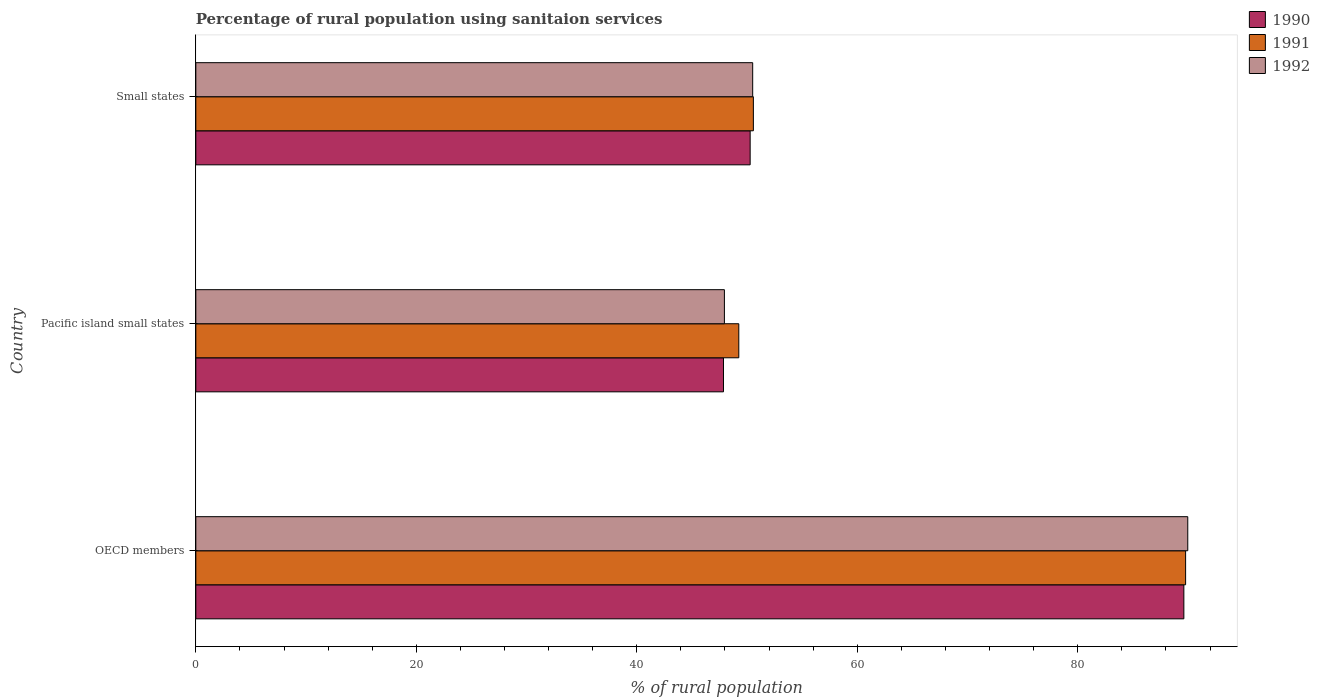Are the number of bars on each tick of the Y-axis equal?
Offer a terse response. Yes. What is the label of the 2nd group of bars from the top?
Offer a terse response. Pacific island small states. In how many cases, is the number of bars for a given country not equal to the number of legend labels?
Provide a succinct answer. 0. What is the percentage of rural population using sanitaion services in 1992 in Small states?
Your answer should be compact. 50.51. Across all countries, what is the maximum percentage of rural population using sanitaion services in 1992?
Offer a terse response. 89.98. Across all countries, what is the minimum percentage of rural population using sanitaion services in 1992?
Ensure brevity in your answer.  47.95. In which country was the percentage of rural population using sanitaion services in 1990 minimum?
Provide a short and direct response. Pacific island small states. What is the total percentage of rural population using sanitaion services in 1990 in the graph?
Provide a succinct answer. 187.77. What is the difference between the percentage of rural population using sanitaion services in 1990 in OECD members and that in Pacific island small states?
Ensure brevity in your answer.  41.76. What is the difference between the percentage of rural population using sanitaion services in 1992 in Pacific island small states and the percentage of rural population using sanitaion services in 1990 in OECD members?
Your response must be concise. -41.68. What is the average percentage of rural population using sanitaion services in 1992 per country?
Your response must be concise. 62.81. What is the difference between the percentage of rural population using sanitaion services in 1992 and percentage of rural population using sanitaion services in 1990 in Pacific island small states?
Give a very brief answer. 0.08. What is the ratio of the percentage of rural population using sanitaion services in 1992 in OECD members to that in Small states?
Your answer should be compact. 1.78. What is the difference between the highest and the second highest percentage of rural population using sanitaion services in 1991?
Your answer should be compact. 39.21. What is the difference between the highest and the lowest percentage of rural population using sanitaion services in 1991?
Offer a very short reply. 40.53. Is the sum of the percentage of rural population using sanitaion services in 1990 in OECD members and Pacific island small states greater than the maximum percentage of rural population using sanitaion services in 1992 across all countries?
Your response must be concise. Yes. What does the 3rd bar from the bottom in OECD members represents?
Offer a very short reply. 1992. How many bars are there?
Offer a terse response. 9. Are all the bars in the graph horizontal?
Offer a terse response. Yes. How many countries are there in the graph?
Offer a terse response. 3. What is the difference between two consecutive major ticks on the X-axis?
Your answer should be very brief. 20. Are the values on the major ticks of X-axis written in scientific E-notation?
Ensure brevity in your answer.  No. Does the graph contain any zero values?
Your response must be concise. No. What is the title of the graph?
Your answer should be compact. Percentage of rural population using sanitaion services. Does "1961" appear as one of the legend labels in the graph?
Give a very brief answer. No. What is the label or title of the X-axis?
Make the answer very short. % of rural population. What is the % of rural population in 1990 in OECD members?
Offer a terse response. 89.63. What is the % of rural population in 1991 in OECD members?
Your response must be concise. 89.78. What is the % of rural population in 1992 in OECD members?
Offer a very short reply. 89.98. What is the % of rural population of 1990 in Pacific island small states?
Your answer should be compact. 47.86. What is the % of rural population of 1991 in Pacific island small states?
Offer a terse response. 49.25. What is the % of rural population in 1992 in Pacific island small states?
Make the answer very short. 47.95. What is the % of rural population of 1990 in Small states?
Offer a terse response. 50.28. What is the % of rural population of 1991 in Small states?
Your answer should be very brief. 50.58. What is the % of rural population of 1992 in Small states?
Make the answer very short. 50.51. Across all countries, what is the maximum % of rural population in 1990?
Provide a short and direct response. 89.63. Across all countries, what is the maximum % of rural population of 1991?
Your response must be concise. 89.78. Across all countries, what is the maximum % of rural population in 1992?
Ensure brevity in your answer.  89.98. Across all countries, what is the minimum % of rural population in 1990?
Your answer should be very brief. 47.86. Across all countries, what is the minimum % of rural population in 1991?
Offer a terse response. 49.25. Across all countries, what is the minimum % of rural population in 1992?
Provide a short and direct response. 47.95. What is the total % of rural population of 1990 in the graph?
Your response must be concise. 187.77. What is the total % of rural population of 1991 in the graph?
Give a very brief answer. 189.61. What is the total % of rural population in 1992 in the graph?
Keep it short and to the point. 188.44. What is the difference between the % of rural population of 1990 in OECD members and that in Pacific island small states?
Make the answer very short. 41.76. What is the difference between the % of rural population in 1991 in OECD members and that in Pacific island small states?
Offer a very short reply. 40.53. What is the difference between the % of rural population of 1992 in OECD members and that in Pacific island small states?
Offer a terse response. 42.03. What is the difference between the % of rural population of 1990 in OECD members and that in Small states?
Your response must be concise. 39.34. What is the difference between the % of rural population of 1991 in OECD members and that in Small states?
Keep it short and to the point. 39.21. What is the difference between the % of rural population of 1992 in OECD members and that in Small states?
Offer a very short reply. 39.47. What is the difference between the % of rural population of 1990 in Pacific island small states and that in Small states?
Your response must be concise. -2.42. What is the difference between the % of rural population of 1991 in Pacific island small states and that in Small states?
Give a very brief answer. -1.32. What is the difference between the % of rural population in 1992 in Pacific island small states and that in Small states?
Ensure brevity in your answer.  -2.57. What is the difference between the % of rural population in 1990 in OECD members and the % of rural population in 1991 in Pacific island small states?
Give a very brief answer. 40.37. What is the difference between the % of rural population in 1990 in OECD members and the % of rural population in 1992 in Pacific island small states?
Your response must be concise. 41.68. What is the difference between the % of rural population in 1991 in OECD members and the % of rural population in 1992 in Pacific island small states?
Offer a very short reply. 41.84. What is the difference between the % of rural population of 1990 in OECD members and the % of rural population of 1991 in Small states?
Ensure brevity in your answer.  39.05. What is the difference between the % of rural population in 1990 in OECD members and the % of rural population in 1992 in Small states?
Make the answer very short. 39.11. What is the difference between the % of rural population of 1991 in OECD members and the % of rural population of 1992 in Small states?
Make the answer very short. 39.27. What is the difference between the % of rural population in 1990 in Pacific island small states and the % of rural population in 1991 in Small states?
Provide a short and direct response. -2.71. What is the difference between the % of rural population of 1990 in Pacific island small states and the % of rural population of 1992 in Small states?
Give a very brief answer. -2.65. What is the difference between the % of rural population of 1991 in Pacific island small states and the % of rural population of 1992 in Small states?
Ensure brevity in your answer.  -1.26. What is the average % of rural population in 1990 per country?
Offer a very short reply. 62.59. What is the average % of rural population in 1991 per country?
Offer a very short reply. 63.2. What is the average % of rural population in 1992 per country?
Your response must be concise. 62.81. What is the difference between the % of rural population in 1990 and % of rural population in 1991 in OECD members?
Ensure brevity in your answer.  -0.16. What is the difference between the % of rural population of 1990 and % of rural population of 1992 in OECD members?
Offer a very short reply. -0.35. What is the difference between the % of rural population of 1991 and % of rural population of 1992 in OECD members?
Make the answer very short. -0.2. What is the difference between the % of rural population in 1990 and % of rural population in 1991 in Pacific island small states?
Keep it short and to the point. -1.39. What is the difference between the % of rural population of 1990 and % of rural population of 1992 in Pacific island small states?
Keep it short and to the point. -0.08. What is the difference between the % of rural population in 1991 and % of rural population in 1992 in Pacific island small states?
Make the answer very short. 1.31. What is the difference between the % of rural population in 1990 and % of rural population in 1991 in Small states?
Provide a succinct answer. -0.29. What is the difference between the % of rural population in 1990 and % of rural population in 1992 in Small states?
Make the answer very short. -0.23. What is the difference between the % of rural population of 1991 and % of rural population of 1992 in Small states?
Offer a very short reply. 0.06. What is the ratio of the % of rural population of 1990 in OECD members to that in Pacific island small states?
Provide a succinct answer. 1.87. What is the ratio of the % of rural population of 1991 in OECD members to that in Pacific island small states?
Your answer should be very brief. 1.82. What is the ratio of the % of rural population of 1992 in OECD members to that in Pacific island small states?
Keep it short and to the point. 1.88. What is the ratio of the % of rural population of 1990 in OECD members to that in Small states?
Give a very brief answer. 1.78. What is the ratio of the % of rural population in 1991 in OECD members to that in Small states?
Keep it short and to the point. 1.78. What is the ratio of the % of rural population in 1992 in OECD members to that in Small states?
Keep it short and to the point. 1.78. What is the ratio of the % of rural population of 1990 in Pacific island small states to that in Small states?
Give a very brief answer. 0.95. What is the ratio of the % of rural population in 1991 in Pacific island small states to that in Small states?
Your answer should be compact. 0.97. What is the ratio of the % of rural population of 1992 in Pacific island small states to that in Small states?
Provide a short and direct response. 0.95. What is the difference between the highest and the second highest % of rural population of 1990?
Offer a very short reply. 39.34. What is the difference between the highest and the second highest % of rural population in 1991?
Make the answer very short. 39.21. What is the difference between the highest and the second highest % of rural population of 1992?
Offer a very short reply. 39.47. What is the difference between the highest and the lowest % of rural population of 1990?
Provide a succinct answer. 41.76. What is the difference between the highest and the lowest % of rural population in 1991?
Provide a short and direct response. 40.53. What is the difference between the highest and the lowest % of rural population of 1992?
Make the answer very short. 42.03. 